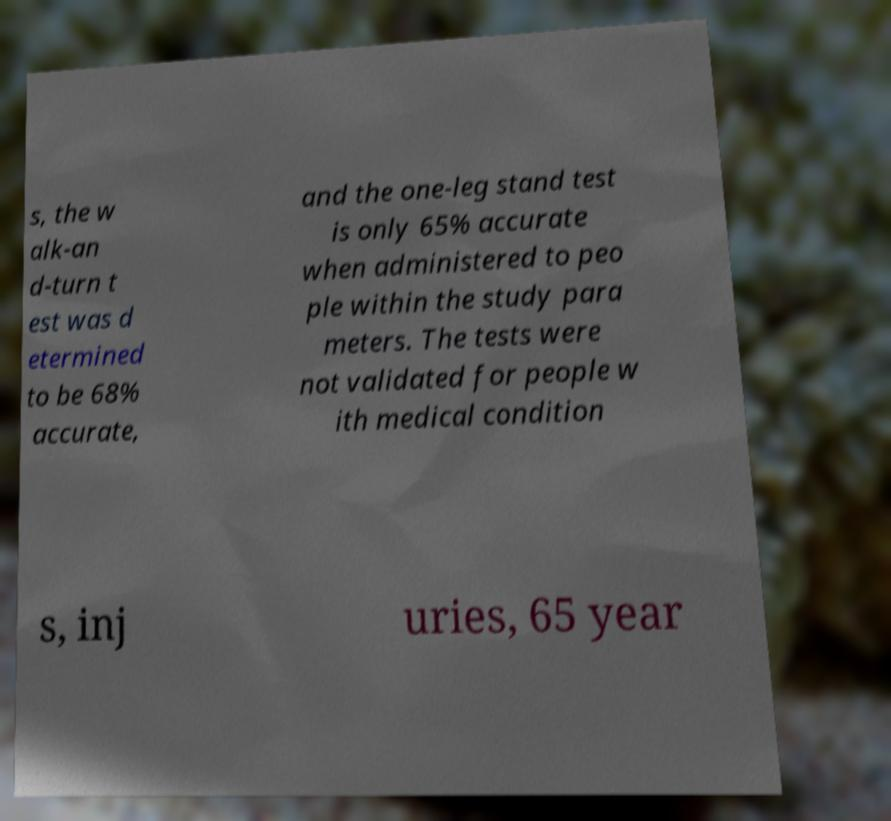Please read and relay the text visible in this image. What does it say? s, the w alk-an d-turn t est was d etermined to be 68% accurate, and the one-leg stand test is only 65% accurate when administered to peo ple within the study para meters. The tests were not validated for people w ith medical condition s, inj uries, 65 year 